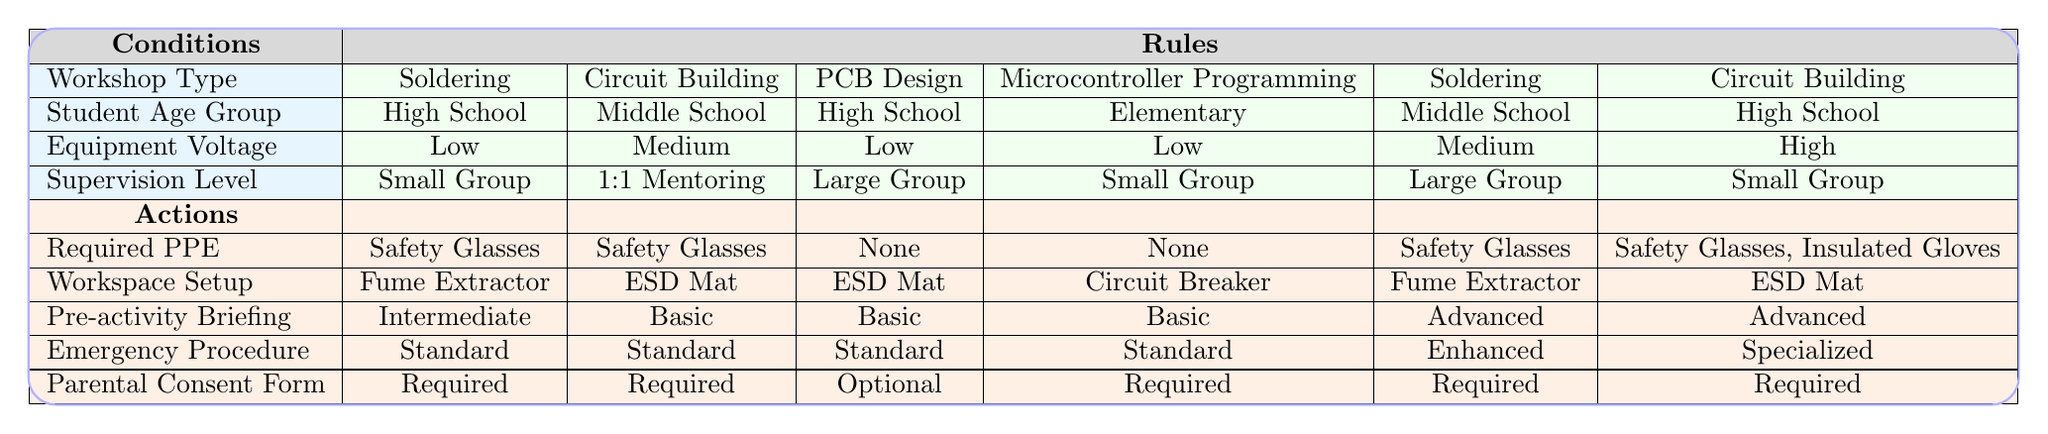What is the required PPE for Microcontroller Programming sessions for Elementary students? For Microcontroller Programming sessions for Elementary students, we look for the specific condition in the table. The row for Microcontroller Programming lists that the required PPE is "None."
Answer: None How many required actions are needed for High School students in Circuit Building sessions? We observe the rule for Circuit Building with High School students. It indicates the actions are "Safety Glasses," "ESD Mat," "Basic," "Standard Protocol," and "Required." This gives us a total of 5 actions.
Answer: 5 Is parental consent required for PCB Design sessions for High School students? By checking the row corresponding to PCB Design in the table, it states that the Parental Consent Form is "Optional" for High School students.
Answer: No What is the difference in the required PPE between Soldering and Circuit Building sessions for High School students? Inspecting the required PPE for Soldering sessions for High School students shows "Safety Glasses," while for Circuit Building, it also shows "Safety Glasses." Therefore, there is no difference in required PPE between the two.
Answer: No difference What are the emergency procedures for Soldering sessions with Middle School students? The Soldering session rule for Middle School students indicates the Emergency Procedure is "Enhanced Protocol." We derive this by identifying the specific conditions met and their corresponding actions.
Answer: Enhanced Protocol If a workshop involves High Voltage equipment in a Small Group setting, what required PPE is mandated? We reference the Circuit Building session rules for High School students using High Voltage in a Small Group setting, which indicates the required PPE includes "Safety Glasses" and "Insulated Gloves." Therefore, both are necessary.
Answer: Safety Glasses, Insulated Gloves What is the percentage of "Standard Protocol" emergency procedures used across all types of workshops? There are 2 occurrences of "Standard Protocol" out of 6 total rules. To get the percentage, we calculate (2/6) * 100%. This results in approximately 33.33%.
Answer: 33.33% How does the workspace setup differ between Microcontroller Programming and PCB Design sessions for High School students? In the table, Workspace Setup for Microcontroller Programming shows "Circuit Breaker," while the setup for PCB Design is "ESD Mat." This indicates a difference in workspace requirements.
Answer: Different setups, Circuit Breaker vs. ESD Mat What is the average age group involved in sessions requiring Enhanced Protocol emergency procedures? The only session that requires Enhanced Protocol is for Middle School Soldering. Thus, the average age group involved is Middle School (12-14).
Answer: Middle School (12-14) 